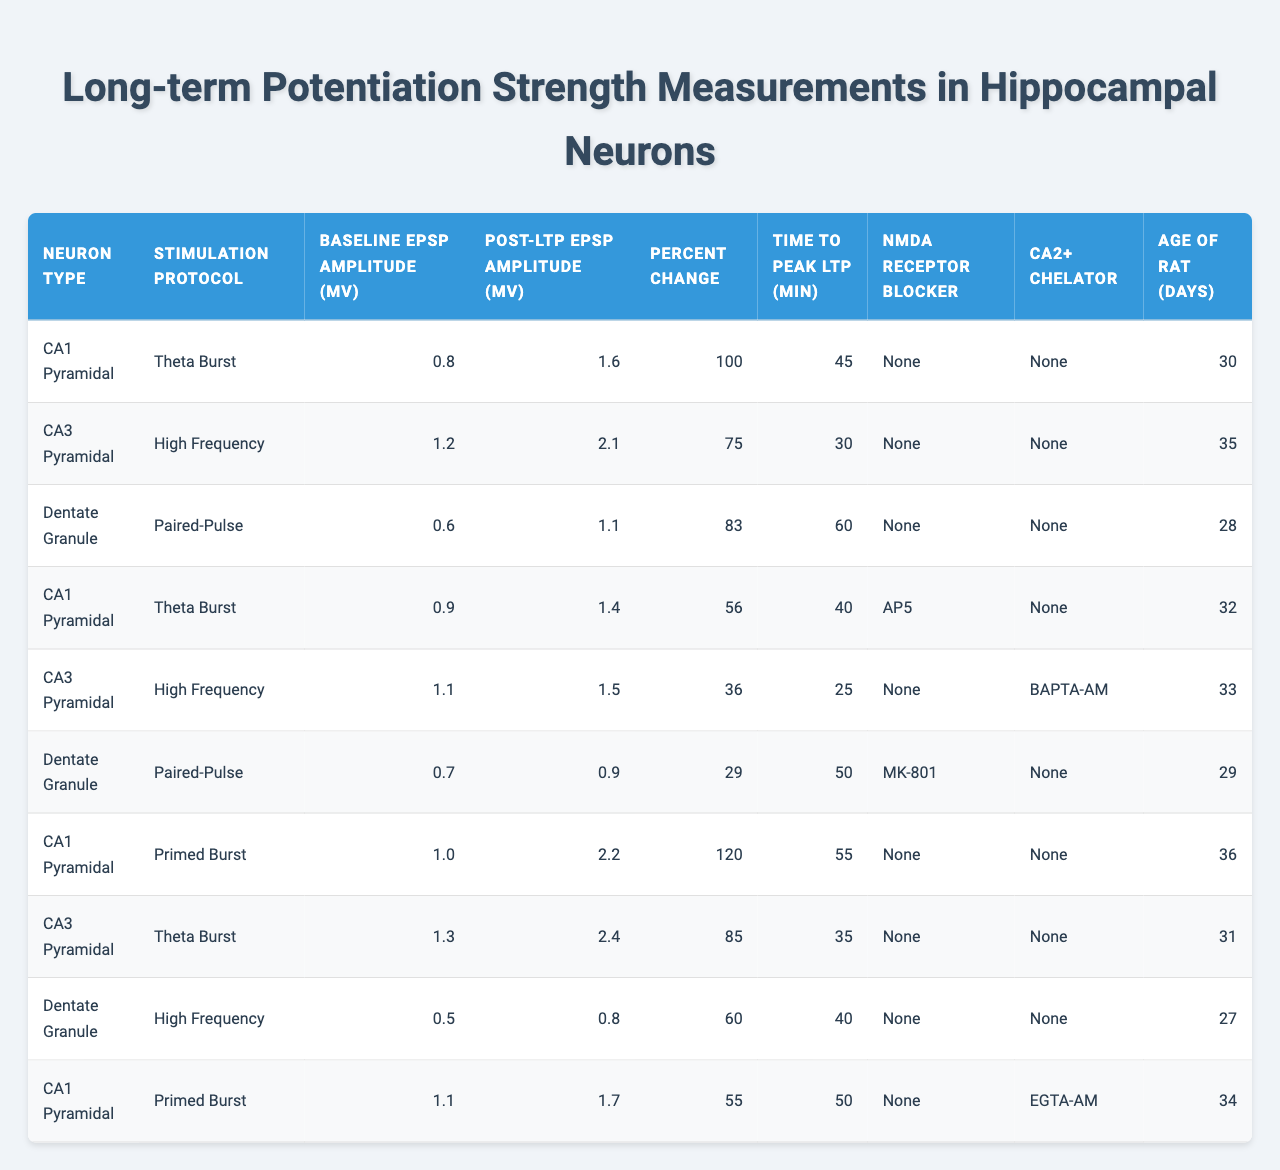What is the baseline EPSP amplitude of CA1 Pyramidal neurons in the Theta Burst protocol? By looking at the column for "Neuron Type" and "Stimulation Protocol," we can find the value for CA1 Pyramidal neurons under the Theta Burst protocol. The table shows a baseline EPSP amplitude of 0.8 mV for this group.
Answer: 0.8 mV What is the percent change in EPSP amplitude for CA3 Pyramidal neurons following High Frequency stimulation? We can identify CA3 Pyramidal neurons under the High Frequency protocol and see that the corresponding Percent Change is 75%. Thus, the percent change in EPSP amplitude is 75%.
Answer: 75% Which neuron type has the highest post-LTP EPSP amplitude? Examining the "Post-LTP EPSP Amplitude" column, we find that CA1 Pyramidal neurons under the Primed Burst protocol have the highest value of 2.2 mV.
Answer: CA1 Pyramidal Did the Dentate Granule neurons show a positive percent change in EPSP amplitude during the High Frequency stimulation? Looking at the Dentate Granule row under the High Frequency stimulation, the percent change is 60%, which is positive. Therefore, the answer is yes.
Answer: Yes Calculate the average time to peak LTP for all neuron types. To find the average, we add the time to peak values: 45 + 30 + 60 + 40 + 25 + 50 + 55 + 35 + 40 + 50 = 430 min. Then, we divide by the number of data points, which is 10: 430/10 = 43 min.
Answer: 43 min Which stimulation protocol had the lowest baseline EPSP amplitude, and what was the value? Scanning the "Baseline EPSP Amplitude" column, Dentate Granule neurons under the High Frequency stimulation had the lowest amplitude, which is 0.5 mV.
Answer: High Frequency, 0.5 mV Do CA1 Pyramidal neurons always show a higher percent change compared to CA3 Pyramidal neurons? Reviewing the percent changes for CA1 Pyramidal (100, 56, 120, 55) and CA3 Pyramidal (75, 36, 85), we see that CA1 Pyramidal neurons display both higher and lower percent changes compared to CA3 across different protocols. Therefore, the statement is false.
Answer: No What is the difference in post-LTP EPSP amplitude between CA1 Pyramidal neurons under Theta Burst and Primed Burst protocols? The post-LTP EPSP amplitude for CA1 Pyramidal under Theta Burst is 1.6 mV and for Primed Burst is 2.2 mV. The difference is 2.2 - 1.6 = 0.6 mV.
Answer: 0.6 mV Which age group of rats yielded the highest percent change in EPSP amplitude, and which neuron type did they belong to? Checking the age of rats and corresponding percent changes, the CA1 Pyramidal neurons in the Primed Burst protocol at 36 days old showed the highest percent change of 120%.
Answer: CA1 Pyramidal, 36 days Are the NMDA receptor blocker effects consistent across all neuron types? Examining the "NMDA Receptor Blocker" column, we see that not all neuron types utilize the same blockers; CA1 Pyramidal had none in some entries, while others used AP5 or MK-801, indicating inconsistency.
Answer: No 